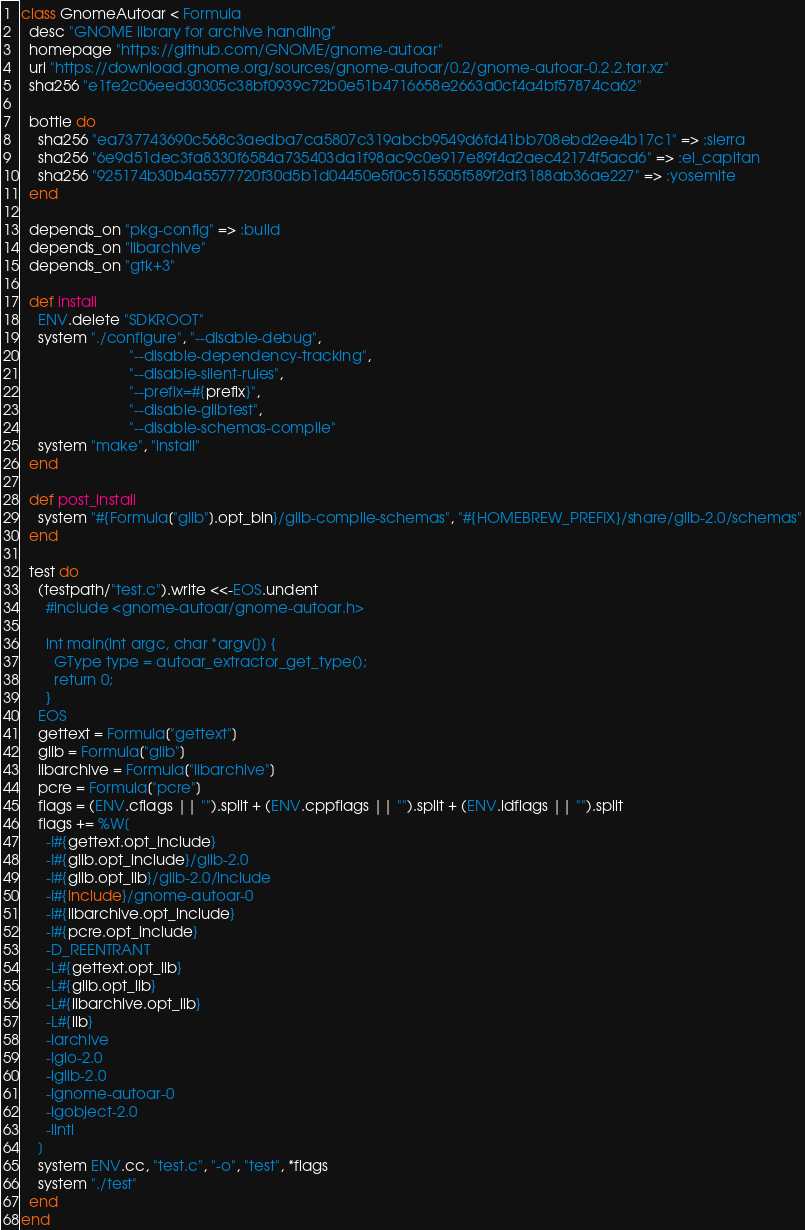Convert code to text. <code><loc_0><loc_0><loc_500><loc_500><_Ruby_>class GnomeAutoar < Formula
  desc "GNOME library for archive handling"
  homepage "https://github.com/GNOME/gnome-autoar"
  url "https://download.gnome.org/sources/gnome-autoar/0.2/gnome-autoar-0.2.2.tar.xz"
  sha256 "e1fe2c06eed30305c38bf0939c72b0e51b4716658e2663a0cf4a4bf57874ca62"

  bottle do
    sha256 "ea737743690c568c3aedba7ca5807c319abcb9549d6fd41bb708ebd2ee4b17c1" => :sierra
    sha256 "6e9d51dec3fa8330f6584a735403da1f98ac9c0e917e89f4a2aec42174f5acd6" => :el_capitan
    sha256 "925174b30b4a5577720f30d5b1d04450e5f0c515505f589f2df3188ab36ae227" => :yosemite
  end

  depends_on "pkg-config" => :build
  depends_on "libarchive"
  depends_on "gtk+3"

  def install
    ENV.delete "SDKROOT"
    system "./configure", "--disable-debug",
                          "--disable-dependency-tracking",
                          "--disable-silent-rules",
                          "--prefix=#{prefix}",
                          "--disable-glibtest",
                          "--disable-schemas-compile"
    system "make", "install"
  end

  def post_install
    system "#{Formula["glib"].opt_bin}/glib-compile-schemas", "#{HOMEBREW_PREFIX}/share/glib-2.0/schemas"
  end

  test do
    (testpath/"test.c").write <<-EOS.undent
      #include <gnome-autoar/gnome-autoar.h>

      int main(int argc, char *argv[]) {
        GType type = autoar_extractor_get_type();
        return 0;
      }
    EOS
    gettext = Formula["gettext"]
    glib = Formula["glib"]
    libarchive = Formula["libarchive"]
    pcre = Formula["pcre"]
    flags = (ENV.cflags || "").split + (ENV.cppflags || "").split + (ENV.ldflags || "").split
    flags += %W[
      -I#{gettext.opt_include}
      -I#{glib.opt_include}/glib-2.0
      -I#{glib.opt_lib}/glib-2.0/include
      -I#{include}/gnome-autoar-0
      -I#{libarchive.opt_include}
      -I#{pcre.opt_include}
      -D_REENTRANT
      -L#{gettext.opt_lib}
      -L#{glib.opt_lib}
      -L#{libarchive.opt_lib}
      -L#{lib}
      -larchive
      -lgio-2.0
      -lglib-2.0
      -lgnome-autoar-0
      -lgobject-2.0
      -lintl
    ]
    system ENV.cc, "test.c", "-o", "test", *flags
    system "./test"
  end
end
</code> 